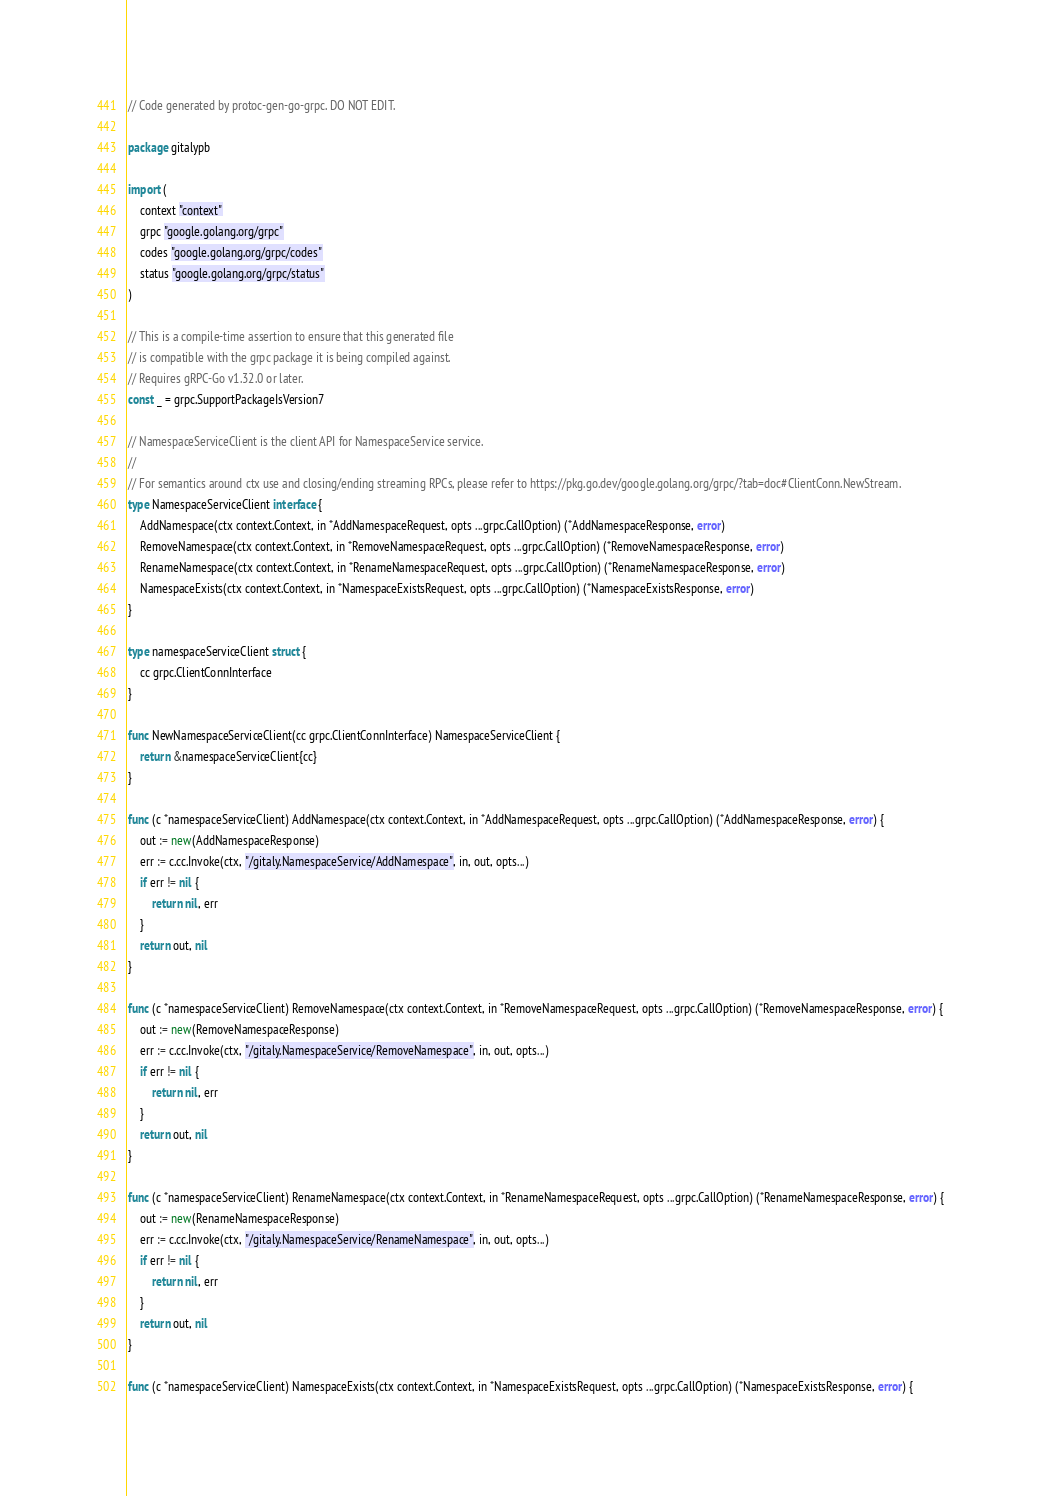Convert code to text. <code><loc_0><loc_0><loc_500><loc_500><_Go_>// Code generated by protoc-gen-go-grpc. DO NOT EDIT.

package gitalypb

import (
	context "context"
	grpc "google.golang.org/grpc"
	codes "google.golang.org/grpc/codes"
	status "google.golang.org/grpc/status"
)

// This is a compile-time assertion to ensure that this generated file
// is compatible with the grpc package it is being compiled against.
// Requires gRPC-Go v1.32.0 or later.
const _ = grpc.SupportPackageIsVersion7

// NamespaceServiceClient is the client API for NamespaceService service.
//
// For semantics around ctx use and closing/ending streaming RPCs, please refer to https://pkg.go.dev/google.golang.org/grpc/?tab=doc#ClientConn.NewStream.
type NamespaceServiceClient interface {
	AddNamespace(ctx context.Context, in *AddNamespaceRequest, opts ...grpc.CallOption) (*AddNamespaceResponse, error)
	RemoveNamespace(ctx context.Context, in *RemoveNamespaceRequest, opts ...grpc.CallOption) (*RemoveNamespaceResponse, error)
	RenameNamespace(ctx context.Context, in *RenameNamespaceRequest, opts ...grpc.CallOption) (*RenameNamespaceResponse, error)
	NamespaceExists(ctx context.Context, in *NamespaceExistsRequest, opts ...grpc.CallOption) (*NamespaceExistsResponse, error)
}

type namespaceServiceClient struct {
	cc grpc.ClientConnInterface
}

func NewNamespaceServiceClient(cc grpc.ClientConnInterface) NamespaceServiceClient {
	return &namespaceServiceClient{cc}
}

func (c *namespaceServiceClient) AddNamespace(ctx context.Context, in *AddNamespaceRequest, opts ...grpc.CallOption) (*AddNamespaceResponse, error) {
	out := new(AddNamespaceResponse)
	err := c.cc.Invoke(ctx, "/gitaly.NamespaceService/AddNamespace", in, out, opts...)
	if err != nil {
		return nil, err
	}
	return out, nil
}

func (c *namespaceServiceClient) RemoveNamespace(ctx context.Context, in *RemoveNamespaceRequest, opts ...grpc.CallOption) (*RemoveNamespaceResponse, error) {
	out := new(RemoveNamespaceResponse)
	err := c.cc.Invoke(ctx, "/gitaly.NamespaceService/RemoveNamespace", in, out, opts...)
	if err != nil {
		return nil, err
	}
	return out, nil
}

func (c *namespaceServiceClient) RenameNamespace(ctx context.Context, in *RenameNamespaceRequest, opts ...grpc.CallOption) (*RenameNamespaceResponse, error) {
	out := new(RenameNamespaceResponse)
	err := c.cc.Invoke(ctx, "/gitaly.NamespaceService/RenameNamespace", in, out, opts...)
	if err != nil {
		return nil, err
	}
	return out, nil
}

func (c *namespaceServiceClient) NamespaceExists(ctx context.Context, in *NamespaceExistsRequest, opts ...grpc.CallOption) (*NamespaceExistsResponse, error) {</code> 